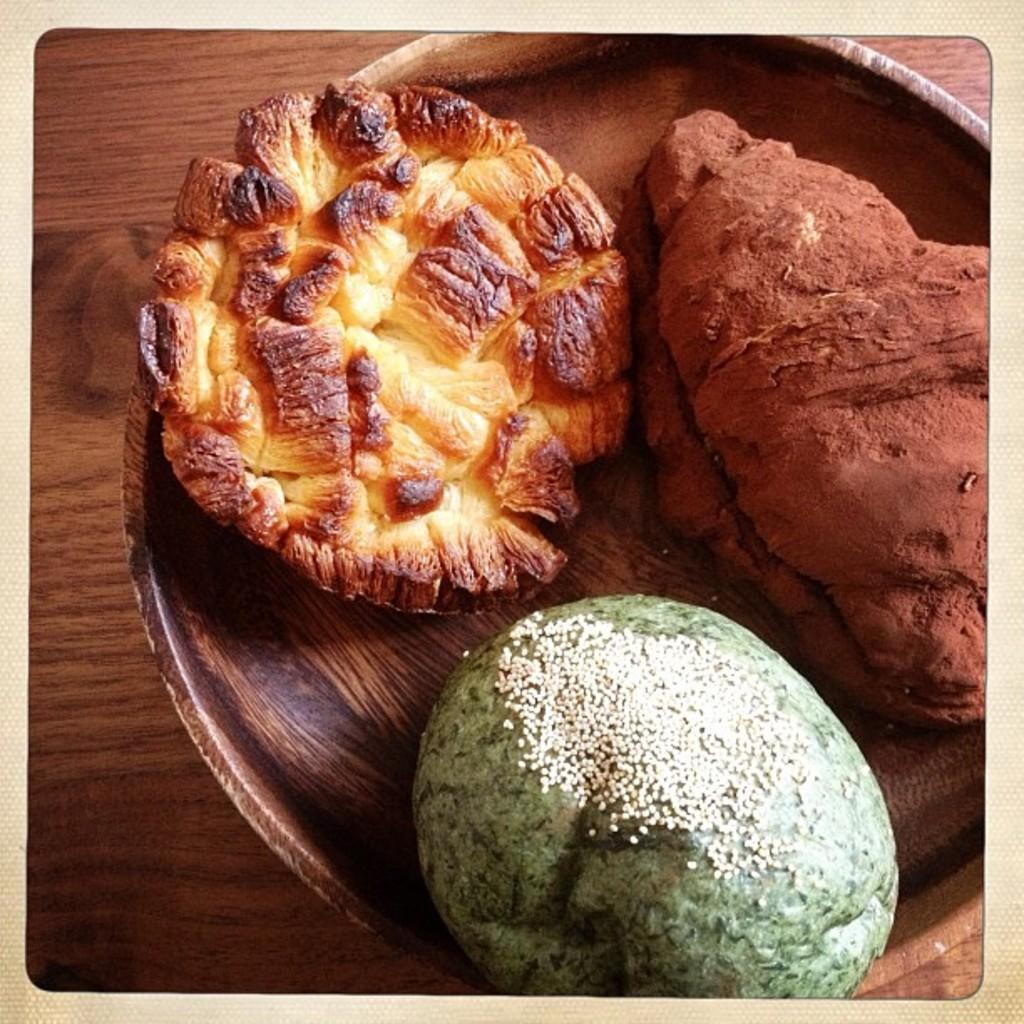What is in the bowl that is visible in the image? There is food in a bowl in the image. What type of surface is the bowl placed on? The bowl is placed on a wooden surface. Where is the sink located in the image? There is no sink present in the image. What type of meeting is taking place in the image? There is no meeting depicted in the image. 